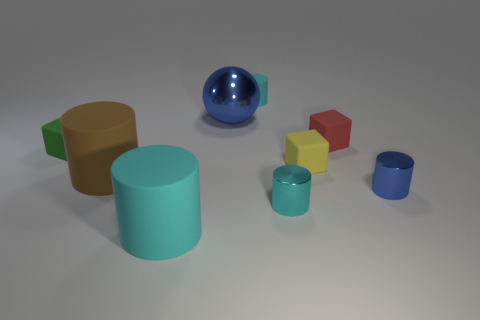Subtract all brown blocks. How many cyan cylinders are left? 3 Subtract all brown cylinders. How many cylinders are left? 4 Subtract all big cyan matte cylinders. How many cylinders are left? 4 Subtract all purple cylinders. Subtract all blue blocks. How many cylinders are left? 5 Subtract all spheres. How many objects are left? 8 Add 7 small cylinders. How many small cylinders are left? 10 Add 6 blue things. How many blue things exist? 8 Subtract 0 yellow balls. How many objects are left? 9 Subtract all tiny brown matte objects. Subtract all red rubber things. How many objects are left? 8 